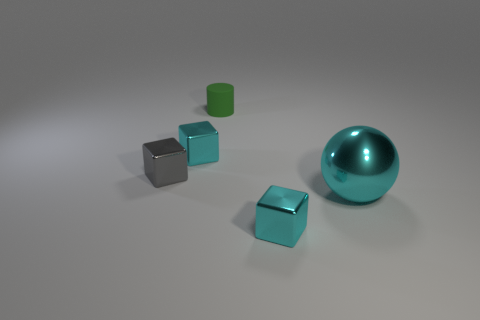Add 2 big metallic spheres. How many objects exist? 7 Subtract all cubes. How many objects are left? 2 Subtract 1 green cylinders. How many objects are left? 4 Subtract all yellow spheres. Subtract all small rubber things. How many objects are left? 4 Add 4 small green rubber things. How many small green rubber things are left? 5 Add 1 big cyan things. How many big cyan things exist? 2 